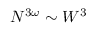<formula> <loc_0><loc_0><loc_500><loc_500>N ^ { 3 \omega } \sim W ^ { 3 }</formula> 